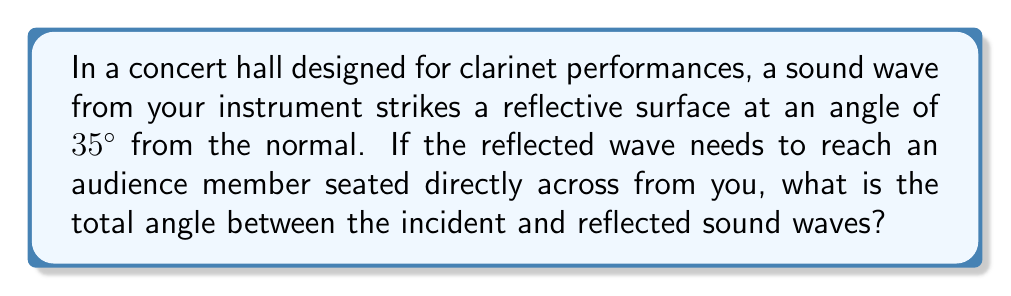Provide a solution to this math problem. Let's approach this step-by-step:

1) First, recall the law of reflection: the angle of incidence equals the angle of reflection.

2) In this case, the angle of incidence is given as 35° from the normal.

3) Due to the law of reflection, the angle of reflection will also be 35° from the normal.

4) To find the total angle between the incident and reflected waves, we need to add these two angles:

   $$\text{Total Angle} = \text{Angle of Incidence} + \text{Angle of Reflection}$$

5) Substituting the values:

   $$\text{Total Angle} = 35° + 35° = 70°$$

This can be visualized as:

[asy]
import geometry;

size(200);

point O=(0,0);
point A=(-2,2);
point B=(2,2);

draw(A--O--B);
draw((-2,0)--(2,0),arrow=Arrow(TeXHead));

label("Normal", (0,-0.5), S);
label("35°", (-1,1.2), NW);
label("35°", (1,1.2), NE);
label("70°", (0,1.5), N);

draw(arc(O,0.5,180,215),arrow=Arrow(TeXHead));
draw(arc(O,0.5,325,360),arrow=Arrow(TeXHead));
[/asy]

6) Therefore, the total angle between the incident and reflected sound waves is 70°.
Answer: 70° 